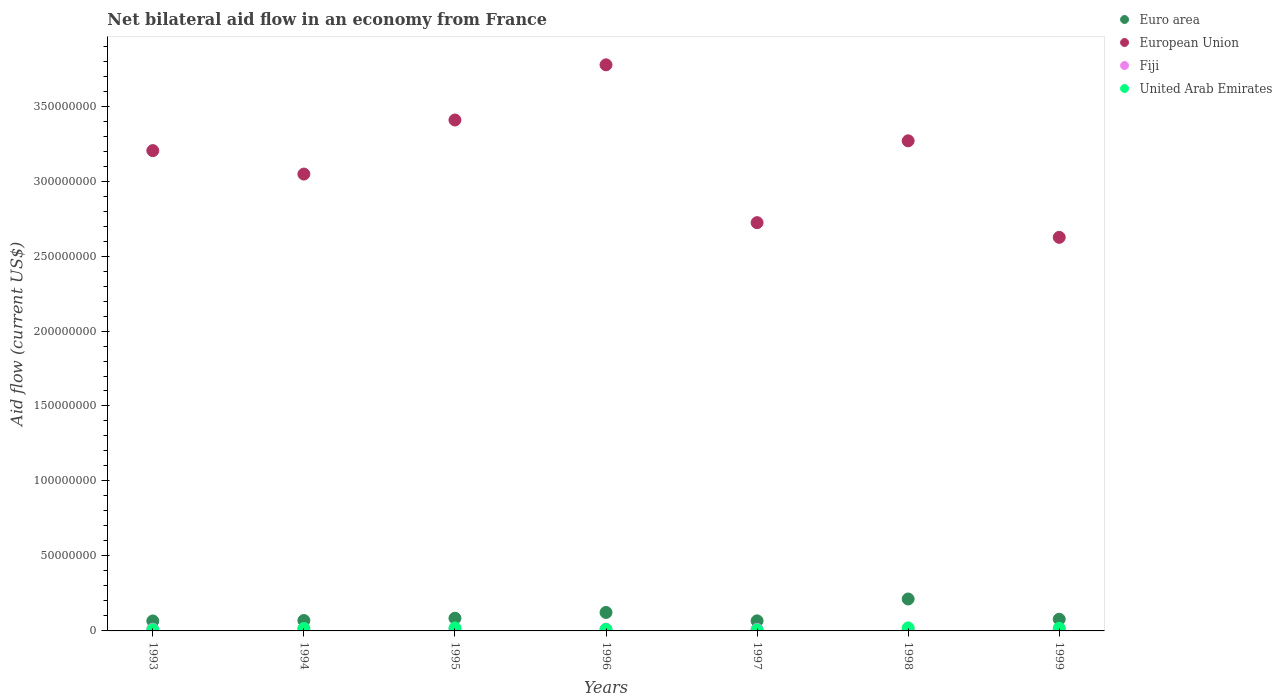How many different coloured dotlines are there?
Your answer should be very brief. 4. What is the net bilateral aid flow in Euro area in 1995?
Offer a very short reply. 8.47e+06. Across all years, what is the maximum net bilateral aid flow in European Union?
Ensure brevity in your answer.  3.78e+08. Across all years, what is the minimum net bilateral aid flow in European Union?
Give a very brief answer. 2.62e+08. In which year was the net bilateral aid flow in United Arab Emirates minimum?
Provide a short and direct response. 1997. What is the total net bilateral aid flow in European Union in the graph?
Give a very brief answer. 2.20e+09. What is the difference between the net bilateral aid flow in United Arab Emirates in 1993 and that in 1995?
Offer a very short reply. -1.20e+06. What is the difference between the net bilateral aid flow in Euro area in 1993 and the net bilateral aid flow in United Arab Emirates in 1994?
Make the answer very short. 5.03e+06. What is the average net bilateral aid flow in European Union per year?
Make the answer very short. 3.15e+08. In the year 1998, what is the difference between the net bilateral aid flow in Fiji and net bilateral aid flow in European Union?
Make the answer very short. -3.26e+08. What is the ratio of the net bilateral aid flow in United Arab Emirates in 1993 to that in 1994?
Keep it short and to the point. 0.49. What is the difference between the highest and the second highest net bilateral aid flow in Euro area?
Provide a short and direct response. 8.98e+06. What is the difference between the highest and the lowest net bilateral aid flow in Fiji?
Ensure brevity in your answer.  7.90e+05. In how many years, is the net bilateral aid flow in Fiji greater than the average net bilateral aid flow in Fiji taken over all years?
Offer a very short reply. 4. Is it the case that in every year, the sum of the net bilateral aid flow in Fiji and net bilateral aid flow in United Arab Emirates  is greater than the net bilateral aid flow in European Union?
Offer a very short reply. No. Does the net bilateral aid flow in European Union monotonically increase over the years?
Give a very brief answer. No. Is the net bilateral aid flow in United Arab Emirates strictly less than the net bilateral aid flow in Euro area over the years?
Give a very brief answer. Yes. How many dotlines are there?
Make the answer very short. 4. Are the values on the major ticks of Y-axis written in scientific E-notation?
Offer a very short reply. No. Does the graph contain any zero values?
Make the answer very short. No. How many legend labels are there?
Make the answer very short. 4. What is the title of the graph?
Give a very brief answer. Net bilateral aid flow in an economy from France. Does "Canada" appear as one of the legend labels in the graph?
Make the answer very short. No. What is the Aid flow (current US$) of Euro area in 1993?
Give a very brief answer. 6.64e+06. What is the Aid flow (current US$) of European Union in 1993?
Make the answer very short. 3.20e+08. What is the Aid flow (current US$) of Fiji in 1993?
Offer a terse response. 1.17e+06. What is the Aid flow (current US$) of United Arab Emirates in 1993?
Provide a short and direct response. 7.90e+05. What is the Aid flow (current US$) in Euro area in 1994?
Give a very brief answer. 6.94e+06. What is the Aid flow (current US$) in European Union in 1994?
Your answer should be very brief. 3.05e+08. What is the Aid flow (current US$) in Fiji in 1994?
Offer a very short reply. 1.35e+06. What is the Aid flow (current US$) in United Arab Emirates in 1994?
Provide a succinct answer. 1.61e+06. What is the Aid flow (current US$) of Euro area in 1995?
Your response must be concise. 8.47e+06. What is the Aid flow (current US$) in European Union in 1995?
Make the answer very short. 3.41e+08. What is the Aid flow (current US$) in Fiji in 1995?
Your answer should be compact. 8.20e+05. What is the Aid flow (current US$) of United Arab Emirates in 1995?
Offer a terse response. 1.99e+06. What is the Aid flow (current US$) in Euro area in 1996?
Your response must be concise. 1.23e+07. What is the Aid flow (current US$) in European Union in 1996?
Offer a terse response. 3.78e+08. What is the Aid flow (current US$) of Fiji in 1996?
Keep it short and to the point. 1.21e+06. What is the Aid flow (current US$) of Euro area in 1997?
Ensure brevity in your answer.  6.72e+06. What is the Aid flow (current US$) of European Union in 1997?
Provide a succinct answer. 2.72e+08. What is the Aid flow (current US$) in Fiji in 1997?
Provide a short and direct response. 1.03e+06. What is the Aid flow (current US$) of United Arab Emirates in 1997?
Offer a very short reply. 6.50e+05. What is the Aid flow (current US$) of Euro area in 1998?
Offer a terse response. 2.13e+07. What is the Aid flow (current US$) of European Union in 1998?
Your response must be concise. 3.27e+08. What is the Aid flow (current US$) of Fiji in 1998?
Keep it short and to the point. 5.60e+05. What is the Aid flow (current US$) of United Arab Emirates in 1998?
Your answer should be very brief. 2.02e+06. What is the Aid flow (current US$) in Euro area in 1999?
Your response must be concise. 7.79e+06. What is the Aid flow (current US$) of European Union in 1999?
Ensure brevity in your answer.  2.62e+08. What is the Aid flow (current US$) of Fiji in 1999?
Make the answer very short. 1.15e+06. What is the Aid flow (current US$) of United Arab Emirates in 1999?
Make the answer very short. 1.75e+06. Across all years, what is the maximum Aid flow (current US$) of Euro area?
Provide a succinct answer. 2.13e+07. Across all years, what is the maximum Aid flow (current US$) in European Union?
Your answer should be very brief. 3.78e+08. Across all years, what is the maximum Aid flow (current US$) of Fiji?
Provide a short and direct response. 1.35e+06. Across all years, what is the maximum Aid flow (current US$) of United Arab Emirates?
Make the answer very short. 2.02e+06. Across all years, what is the minimum Aid flow (current US$) of Euro area?
Ensure brevity in your answer.  6.64e+06. Across all years, what is the minimum Aid flow (current US$) of European Union?
Provide a short and direct response. 2.62e+08. Across all years, what is the minimum Aid flow (current US$) in Fiji?
Ensure brevity in your answer.  5.60e+05. Across all years, what is the minimum Aid flow (current US$) in United Arab Emirates?
Give a very brief answer. 6.50e+05. What is the total Aid flow (current US$) in Euro area in the graph?
Make the answer very short. 7.02e+07. What is the total Aid flow (current US$) of European Union in the graph?
Your response must be concise. 2.20e+09. What is the total Aid flow (current US$) in Fiji in the graph?
Keep it short and to the point. 7.29e+06. What is the total Aid flow (current US$) in United Arab Emirates in the graph?
Your response must be concise. 9.81e+06. What is the difference between the Aid flow (current US$) in Euro area in 1993 and that in 1994?
Provide a succinct answer. -3.00e+05. What is the difference between the Aid flow (current US$) of European Union in 1993 and that in 1994?
Keep it short and to the point. 1.56e+07. What is the difference between the Aid flow (current US$) in Fiji in 1993 and that in 1994?
Offer a terse response. -1.80e+05. What is the difference between the Aid flow (current US$) of United Arab Emirates in 1993 and that in 1994?
Provide a short and direct response. -8.20e+05. What is the difference between the Aid flow (current US$) in Euro area in 1993 and that in 1995?
Keep it short and to the point. -1.83e+06. What is the difference between the Aid flow (current US$) of European Union in 1993 and that in 1995?
Your answer should be compact. -2.04e+07. What is the difference between the Aid flow (current US$) of United Arab Emirates in 1993 and that in 1995?
Ensure brevity in your answer.  -1.20e+06. What is the difference between the Aid flow (current US$) in Euro area in 1993 and that in 1996?
Keep it short and to the point. -5.67e+06. What is the difference between the Aid flow (current US$) in European Union in 1993 and that in 1996?
Your answer should be very brief. -5.72e+07. What is the difference between the Aid flow (current US$) of European Union in 1993 and that in 1997?
Offer a very short reply. 4.80e+07. What is the difference between the Aid flow (current US$) of United Arab Emirates in 1993 and that in 1997?
Keep it short and to the point. 1.40e+05. What is the difference between the Aid flow (current US$) of Euro area in 1993 and that in 1998?
Your answer should be compact. -1.46e+07. What is the difference between the Aid flow (current US$) of European Union in 1993 and that in 1998?
Ensure brevity in your answer.  -6.53e+06. What is the difference between the Aid flow (current US$) in United Arab Emirates in 1993 and that in 1998?
Your response must be concise. -1.23e+06. What is the difference between the Aid flow (current US$) in Euro area in 1993 and that in 1999?
Your response must be concise. -1.15e+06. What is the difference between the Aid flow (current US$) in European Union in 1993 and that in 1999?
Give a very brief answer. 5.78e+07. What is the difference between the Aid flow (current US$) in United Arab Emirates in 1993 and that in 1999?
Provide a short and direct response. -9.60e+05. What is the difference between the Aid flow (current US$) in Euro area in 1994 and that in 1995?
Provide a succinct answer. -1.53e+06. What is the difference between the Aid flow (current US$) of European Union in 1994 and that in 1995?
Provide a succinct answer. -3.61e+07. What is the difference between the Aid flow (current US$) of Fiji in 1994 and that in 1995?
Your answer should be very brief. 5.30e+05. What is the difference between the Aid flow (current US$) in United Arab Emirates in 1994 and that in 1995?
Your response must be concise. -3.80e+05. What is the difference between the Aid flow (current US$) of Euro area in 1994 and that in 1996?
Offer a terse response. -5.37e+06. What is the difference between the Aid flow (current US$) in European Union in 1994 and that in 1996?
Make the answer very short. -7.28e+07. What is the difference between the Aid flow (current US$) of Fiji in 1994 and that in 1996?
Ensure brevity in your answer.  1.40e+05. What is the difference between the Aid flow (current US$) of Euro area in 1994 and that in 1997?
Your answer should be compact. 2.20e+05. What is the difference between the Aid flow (current US$) of European Union in 1994 and that in 1997?
Provide a succinct answer. 3.24e+07. What is the difference between the Aid flow (current US$) in United Arab Emirates in 1994 and that in 1997?
Offer a very short reply. 9.60e+05. What is the difference between the Aid flow (current US$) in Euro area in 1994 and that in 1998?
Your answer should be compact. -1.44e+07. What is the difference between the Aid flow (current US$) of European Union in 1994 and that in 1998?
Make the answer very short. -2.22e+07. What is the difference between the Aid flow (current US$) of Fiji in 1994 and that in 1998?
Offer a very short reply. 7.90e+05. What is the difference between the Aid flow (current US$) in United Arab Emirates in 1994 and that in 1998?
Keep it short and to the point. -4.10e+05. What is the difference between the Aid flow (current US$) in Euro area in 1994 and that in 1999?
Provide a short and direct response. -8.50e+05. What is the difference between the Aid flow (current US$) of European Union in 1994 and that in 1999?
Ensure brevity in your answer.  4.22e+07. What is the difference between the Aid flow (current US$) of United Arab Emirates in 1994 and that in 1999?
Your answer should be compact. -1.40e+05. What is the difference between the Aid flow (current US$) of Euro area in 1995 and that in 1996?
Make the answer very short. -3.84e+06. What is the difference between the Aid flow (current US$) of European Union in 1995 and that in 1996?
Ensure brevity in your answer.  -3.68e+07. What is the difference between the Aid flow (current US$) in Fiji in 1995 and that in 1996?
Provide a succinct answer. -3.90e+05. What is the difference between the Aid flow (current US$) in United Arab Emirates in 1995 and that in 1996?
Keep it short and to the point. 9.90e+05. What is the difference between the Aid flow (current US$) of Euro area in 1995 and that in 1997?
Your answer should be very brief. 1.75e+06. What is the difference between the Aid flow (current US$) of European Union in 1995 and that in 1997?
Ensure brevity in your answer.  6.85e+07. What is the difference between the Aid flow (current US$) in United Arab Emirates in 1995 and that in 1997?
Offer a terse response. 1.34e+06. What is the difference between the Aid flow (current US$) in Euro area in 1995 and that in 1998?
Provide a succinct answer. -1.28e+07. What is the difference between the Aid flow (current US$) of European Union in 1995 and that in 1998?
Your answer should be compact. 1.39e+07. What is the difference between the Aid flow (current US$) of Euro area in 1995 and that in 1999?
Provide a succinct answer. 6.80e+05. What is the difference between the Aid flow (current US$) of European Union in 1995 and that in 1999?
Give a very brief answer. 7.83e+07. What is the difference between the Aid flow (current US$) in Fiji in 1995 and that in 1999?
Your response must be concise. -3.30e+05. What is the difference between the Aid flow (current US$) in Euro area in 1996 and that in 1997?
Your answer should be very brief. 5.59e+06. What is the difference between the Aid flow (current US$) in European Union in 1996 and that in 1997?
Offer a very short reply. 1.05e+08. What is the difference between the Aid flow (current US$) of United Arab Emirates in 1996 and that in 1997?
Make the answer very short. 3.50e+05. What is the difference between the Aid flow (current US$) of Euro area in 1996 and that in 1998?
Your answer should be very brief. -8.98e+06. What is the difference between the Aid flow (current US$) of European Union in 1996 and that in 1998?
Offer a terse response. 5.07e+07. What is the difference between the Aid flow (current US$) in Fiji in 1996 and that in 1998?
Give a very brief answer. 6.50e+05. What is the difference between the Aid flow (current US$) of United Arab Emirates in 1996 and that in 1998?
Make the answer very short. -1.02e+06. What is the difference between the Aid flow (current US$) of Euro area in 1996 and that in 1999?
Provide a short and direct response. 4.52e+06. What is the difference between the Aid flow (current US$) in European Union in 1996 and that in 1999?
Your answer should be very brief. 1.15e+08. What is the difference between the Aid flow (current US$) of Fiji in 1996 and that in 1999?
Provide a short and direct response. 6.00e+04. What is the difference between the Aid flow (current US$) of United Arab Emirates in 1996 and that in 1999?
Your answer should be very brief. -7.50e+05. What is the difference between the Aid flow (current US$) in Euro area in 1997 and that in 1998?
Provide a succinct answer. -1.46e+07. What is the difference between the Aid flow (current US$) in European Union in 1997 and that in 1998?
Your response must be concise. -5.46e+07. What is the difference between the Aid flow (current US$) in Fiji in 1997 and that in 1998?
Offer a very short reply. 4.70e+05. What is the difference between the Aid flow (current US$) in United Arab Emirates in 1997 and that in 1998?
Give a very brief answer. -1.37e+06. What is the difference between the Aid flow (current US$) of Euro area in 1997 and that in 1999?
Your answer should be very brief. -1.07e+06. What is the difference between the Aid flow (current US$) in European Union in 1997 and that in 1999?
Provide a succinct answer. 9.80e+06. What is the difference between the Aid flow (current US$) of United Arab Emirates in 1997 and that in 1999?
Ensure brevity in your answer.  -1.10e+06. What is the difference between the Aid flow (current US$) of Euro area in 1998 and that in 1999?
Offer a very short reply. 1.35e+07. What is the difference between the Aid flow (current US$) of European Union in 1998 and that in 1999?
Give a very brief answer. 6.44e+07. What is the difference between the Aid flow (current US$) of Fiji in 1998 and that in 1999?
Give a very brief answer. -5.90e+05. What is the difference between the Aid flow (current US$) in United Arab Emirates in 1998 and that in 1999?
Provide a short and direct response. 2.70e+05. What is the difference between the Aid flow (current US$) of Euro area in 1993 and the Aid flow (current US$) of European Union in 1994?
Give a very brief answer. -2.98e+08. What is the difference between the Aid flow (current US$) of Euro area in 1993 and the Aid flow (current US$) of Fiji in 1994?
Your response must be concise. 5.29e+06. What is the difference between the Aid flow (current US$) of Euro area in 1993 and the Aid flow (current US$) of United Arab Emirates in 1994?
Offer a very short reply. 5.03e+06. What is the difference between the Aid flow (current US$) of European Union in 1993 and the Aid flow (current US$) of Fiji in 1994?
Provide a short and direct response. 3.19e+08. What is the difference between the Aid flow (current US$) in European Union in 1993 and the Aid flow (current US$) in United Arab Emirates in 1994?
Your answer should be compact. 3.19e+08. What is the difference between the Aid flow (current US$) in Fiji in 1993 and the Aid flow (current US$) in United Arab Emirates in 1994?
Ensure brevity in your answer.  -4.40e+05. What is the difference between the Aid flow (current US$) in Euro area in 1993 and the Aid flow (current US$) in European Union in 1995?
Keep it short and to the point. -3.34e+08. What is the difference between the Aid flow (current US$) in Euro area in 1993 and the Aid flow (current US$) in Fiji in 1995?
Your answer should be compact. 5.82e+06. What is the difference between the Aid flow (current US$) of Euro area in 1993 and the Aid flow (current US$) of United Arab Emirates in 1995?
Your answer should be compact. 4.65e+06. What is the difference between the Aid flow (current US$) of European Union in 1993 and the Aid flow (current US$) of Fiji in 1995?
Offer a very short reply. 3.19e+08. What is the difference between the Aid flow (current US$) of European Union in 1993 and the Aid flow (current US$) of United Arab Emirates in 1995?
Keep it short and to the point. 3.18e+08. What is the difference between the Aid flow (current US$) of Fiji in 1993 and the Aid flow (current US$) of United Arab Emirates in 1995?
Make the answer very short. -8.20e+05. What is the difference between the Aid flow (current US$) in Euro area in 1993 and the Aid flow (current US$) in European Union in 1996?
Provide a short and direct response. -3.71e+08. What is the difference between the Aid flow (current US$) in Euro area in 1993 and the Aid flow (current US$) in Fiji in 1996?
Offer a terse response. 5.43e+06. What is the difference between the Aid flow (current US$) in Euro area in 1993 and the Aid flow (current US$) in United Arab Emirates in 1996?
Offer a very short reply. 5.64e+06. What is the difference between the Aid flow (current US$) of European Union in 1993 and the Aid flow (current US$) of Fiji in 1996?
Keep it short and to the point. 3.19e+08. What is the difference between the Aid flow (current US$) of European Union in 1993 and the Aid flow (current US$) of United Arab Emirates in 1996?
Your response must be concise. 3.19e+08. What is the difference between the Aid flow (current US$) of Euro area in 1993 and the Aid flow (current US$) of European Union in 1997?
Provide a succinct answer. -2.66e+08. What is the difference between the Aid flow (current US$) in Euro area in 1993 and the Aid flow (current US$) in Fiji in 1997?
Give a very brief answer. 5.61e+06. What is the difference between the Aid flow (current US$) in Euro area in 1993 and the Aid flow (current US$) in United Arab Emirates in 1997?
Provide a short and direct response. 5.99e+06. What is the difference between the Aid flow (current US$) of European Union in 1993 and the Aid flow (current US$) of Fiji in 1997?
Make the answer very short. 3.19e+08. What is the difference between the Aid flow (current US$) in European Union in 1993 and the Aid flow (current US$) in United Arab Emirates in 1997?
Provide a succinct answer. 3.20e+08. What is the difference between the Aid flow (current US$) of Fiji in 1993 and the Aid flow (current US$) of United Arab Emirates in 1997?
Offer a very short reply. 5.20e+05. What is the difference between the Aid flow (current US$) in Euro area in 1993 and the Aid flow (current US$) in European Union in 1998?
Offer a very short reply. -3.20e+08. What is the difference between the Aid flow (current US$) of Euro area in 1993 and the Aid flow (current US$) of Fiji in 1998?
Keep it short and to the point. 6.08e+06. What is the difference between the Aid flow (current US$) of Euro area in 1993 and the Aid flow (current US$) of United Arab Emirates in 1998?
Your answer should be compact. 4.62e+06. What is the difference between the Aid flow (current US$) of European Union in 1993 and the Aid flow (current US$) of Fiji in 1998?
Your answer should be compact. 3.20e+08. What is the difference between the Aid flow (current US$) of European Union in 1993 and the Aid flow (current US$) of United Arab Emirates in 1998?
Your answer should be very brief. 3.18e+08. What is the difference between the Aid flow (current US$) in Fiji in 1993 and the Aid flow (current US$) in United Arab Emirates in 1998?
Your answer should be very brief. -8.50e+05. What is the difference between the Aid flow (current US$) of Euro area in 1993 and the Aid flow (current US$) of European Union in 1999?
Your answer should be compact. -2.56e+08. What is the difference between the Aid flow (current US$) in Euro area in 1993 and the Aid flow (current US$) in Fiji in 1999?
Ensure brevity in your answer.  5.49e+06. What is the difference between the Aid flow (current US$) of Euro area in 1993 and the Aid flow (current US$) of United Arab Emirates in 1999?
Give a very brief answer. 4.89e+06. What is the difference between the Aid flow (current US$) in European Union in 1993 and the Aid flow (current US$) in Fiji in 1999?
Offer a terse response. 3.19e+08. What is the difference between the Aid flow (current US$) of European Union in 1993 and the Aid flow (current US$) of United Arab Emirates in 1999?
Give a very brief answer. 3.19e+08. What is the difference between the Aid flow (current US$) in Fiji in 1993 and the Aid flow (current US$) in United Arab Emirates in 1999?
Offer a terse response. -5.80e+05. What is the difference between the Aid flow (current US$) of Euro area in 1994 and the Aid flow (current US$) of European Union in 1995?
Your response must be concise. -3.34e+08. What is the difference between the Aid flow (current US$) in Euro area in 1994 and the Aid flow (current US$) in Fiji in 1995?
Provide a succinct answer. 6.12e+06. What is the difference between the Aid flow (current US$) of Euro area in 1994 and the Aid flow (current US$) of United Arab Emirates in 1995?
Provide a succinct answer. 4.95e+06. What is the difference between the Aid flow (current US$) of European Union in 1994 and the Aid flow (current US$) of Fiji in 1995?
Ensure brevity in your answer.  3.04e+08. What is the difference between the Aid flow (current US$) of European Union in 1994 and the Aid flow (current US$) of United Arab Emirates in 1995?
Make the answer very short. 3.03e+08. What is the difference between the Aid flow (current US$) of Fiji in 1994 and the Aid flow (current US$) of United Arab Emirates in 1995?
Make the answer very short. -6.40e+05. What is the difference between the Aid flow (current US$) in Euro area in 1994 and the Aid flow (current US$) in European Union in 1996?
Give a very brief answer. -3.71e+08. What is the difference between the Aid flow (current US$) in Euro area in 1994 and the Aid flow (current US$) in Fiji in 1996?
Provide a succinct answer. 5.73e+06. What is the difference between the Aid flow (current US$) in Euro area in 1994 and the Aid flow (current US$) in United Arab Emirates in 1996?
Provide a short and direct response. 5.94e+06. What is the difference between the Aid flow (current US$) in European Union in 1994 and the Aid flow (current US$) in Fiji in 1996?
Provide a short and direct response. 3.03e+08. What is the difference between the Aid flow (current US$) in European Union in 1994 and the Aid flow (current US$) in United Arab Emirates in 1996?
Offer a terse response. 3.04e+08. What is the difference between the Aid flow (current US$) of Fiji in 1994 and the Aid flow (current US$) of United Arab Emirates in 1996?
Your answer should be compact. 3.50e+05. What is the difference between the Aid flow (current US$) in Euro area in 1994 and the Aid flow (current US$) in European Union in 1997?
Make the answer very short. -2.65e+08. What is the difference between the Aid flow (current US$) of Euro area in 1994 and the Aid flow (current US$) of Fiji in 1997?
Offer a terse response. 5.91e+06. What is the difference between the Aid flow (current US$) in Euro area in 1994 and the Aid flow (current US$) in United Arab Emirates in 1997?
Your answer should be compact. 6.29e+06. What is the difference between the Aid flow (current US$) of European Union in 1994 and the Aid flow (current US$) of Fiji in 1997?
Offer a very short reply. 3.04e+08. What is the difference between the Aid flow (current US$) of European Union in 1994 and the Aid flow (current US$) of United Arab Emirates in 1997?
Offer a very short reply. 3.04e+08. What is the difference between the Aid flow (current US$) in Fiji in 1994 and the Aid flow (current US$) in United Arab Emirates in 1997?
Your response must be concise. 7.00e+05. What is the difference between the Aid flow (current US$) of Euro area in 1994 and the Aid flow (current US$) of European Union in 1998?
Offer a terse response. -3.20e+08. What is the difference between the Aid flow (current US$) in Euro area in 1994 and the Aid flow (current US$) in Fiji in 1998?
Offer a very short reply. 6.38e+06. What is the difference between the Aid flow (current US$) in Euro area in 1994 and the Aid flow (current US$) in United Arab Emirates in 1998?
Offer a terse response. 4.92e+06. What is the difference between the Aid flow (current US$) in European Union in 1994 and the Aid flow (current US$) in Fiji in 1998?
Your answer should be compact. 3.04e+08. What is the difference between the Aid flow (current US$) in European Union in 1994 and the Aid flow (current US$) in United Arab Emirates in 1998?
Offer a very short reply. 3.03e+08. What is the difference between the Aid flow (current US$) of Fiji in 1994 and the Aid flow (current US$) of United Arab Emirates in 1998?
Your answer should be compact. -6.70e+05. What is the difference between the Aid flow (current US$) of Euro area in 1994 and the Aid flow (current US$) of European Union in 1999?
Offer a very short reply. -2.56e+08. What is the difference between the Aid flow (current US$) in Euro area in 1994 and the Aid flow (current US$) in Fiji in 1999?
Offer a terse response. 5.79e+06. What is the difference between the Aid flow (current US$) of Euro area in 1994 and the Aid flow (current US$) of United Arab Emirates in 1999?
Keep it short and to the point. 5.19e+06. What is the difference between the Aid flow (current US$) in European Union in 1994 and the Aid flow (current US$) in Fiji in 1999?
Offer a terse response. 3.04e+08. What is the difference between the Aid flow (current US$) of European Union in 1994 and the Aid flow (current US$) of United Arab Emirates in 1999?
Ensure brevity in your answer.  3.03e+08. What is the difference between the Aid flow (current US$) of Fiji in 1994 and the Aid flow (current US$) of United Arab Emirates in 1999?
Ensure brevity in your answer.  -4.00e+05. What is the difference between the Aid flow (current US$) in Euro area in 1995 and the Aid flow (current US$) in European Union in 1996?
Ensure brevity in your answer.  -3.69e+08. What is the difference between the Aid flow (current US$) of Euro area in 1995 and the Aid flow (current US$) of Fiji in 1996?
Your answer should be compact. 7.26e+06. What is the difference between the Aid flow (current US$) of Euro area in 1995 and the Aid flow (current US$) of United Arab Emirates in 1996?
Your answer should be compact. 7.47e+06. What is the difference between the Aid flow (current US$) in European Union in 1995 and the Aid flow (current US$) in Fiji in 1996?
Ensure brevity in your answer.  3.40e+08. What is the difference between the Aid flow (current US$) in European Union in 1995 and the Aid flow (current US$) in United Arab Emirates in 1996?
Provide a short and direct response. 3.40e+08. What is the difference between the Aid flow (current US$) of Euro area in 1995 and the Aid flow (current US$) of European Union in 1997?
Make the answer very short. -2.64e+08. What is the difference between the Aid flow (current US$) of Euro area in 1995 and the Aid flow (current US$) of Fiji in 1997?
Offer a terse response. 7.44e+06. What is the difference between the Aid flow (current US$) in Euro area in 1995 and the Aid flow (current US$) in United Arab Emirates in 1997?
Ensure brevity in your answer.  7.82e+06. What is the difference between the Aid flow (current US$) in European Union in 1995 and the Aid flow (current US$) in Fiji in 1997?
Keep it short and to the point. 3.40e+08. What is the difference between the Aid flow (current US$) in European Union in 1995 and the Aid flow (current US$) in United Arab Emirates in 1997?
Ensure brevity in your answer.  3.40e+08. What is the difference between the Aid flow (current US$) in Fiji in 1995 and the Aid flow (current US$) in United Arab Emirates in 1997?
Ensure brevity in your answer.  1.70e+05. What is the difference between the Aid flow (current US$) in Euro area in 1995 and the Aid flow (current US$) in European Union in 1998?
Keep it short and to the point. -3.18e+08. What is the difference between the Aid flow (current US$) in Euro area in 1995 and the Aid flow (current US$) in Fiji in 1998?
Provide a short and direct response. 7.91e+06. What is the difference between the Aid flow (current US$) of Euro area in 1995 and the Aid flow (current US$) of United Arab Emirates in 1998?
Provide a short and direct response. 6.45e+06. What is the difference between the Aid flow (current US$) of European Union in 1995 and the Aid flow (current US$) of Fiji in 1998?
Offer a terse response. 3.40e+08. What is the difference between the Aid flow (current US$) of European Union in 1995 and the Aid flow (current US$) of United Arab Emirates in 1998?
Your response must be concise. 3.39e+08. What is the difference between the Aid flow (current US$) of Fiji in 1995 and the Aid flow (current US$) of United Arab Emirates in 1998?
Ensure brevity in your answer.  -1.20e+06. What is the difference between the Aid flow (current US$) of Euro area in 1995 and the Aid flow (current US$) of European Union in 1999?
Make the answer very short. -2.54e+08. What is the difference between the Aid flow (current US$) of Euro area in 1995 and the Aid flow (current US$) of Fiji in 1999?
Provide a succinct answer. 7.32e+06. What is the difference between the Aid flow (current US$) of Euro area in 1995 and the Aid flow (current US$) of United Arab Emirates in 1999?
Keep it short and to the point. 6.72e+06. What is the difference between the Aid flow (current US$) in European Union in 1995 and the Aid flow (current US$) in Fiji in 1999?
Your answer should be very brief. 3.40e+08. What is the difference between the Aid flow (current US$) of European Union in 1995 and the Aid flow (current US$) of United Arab Emirates in 1999?
Give a very brief answer. 3.39e+08. What is the difference between the Aid flow (current US$) of Fiji in 1995 and the Aid flow (current US$) of United Arab Emirates in 1999?
Make the answer very short. -9.30e+05. What is the difference between the Aid flow (current US$) in Euro area in 1996 and the Aid flow (current US$) in European Union in 1997?
Your answer should be compact. -2.60e+08. What is the difference between the Aid flow (current US$) in Euro area in 1996 and the Aid flow (current US$) in Fiji in 1997?
Provide a short and direct response. 1.13e+07. What is the difference between the Aid flow (current US$) of Euro area in 1996 and the Aid flow (current US$) of United Arab Emirates in 1997?
Offer a very short reply. 1.17e+07. What is the difference between the Aid flow (current US$) of European Union in 1996 and the Aid flow (current US$) of Fiji in 1997?
Give a very brief answer. 3.76e+08. What is the difference between the Aid flow (current US$) of European Union in 1996 and the Aid flow (current US$) of United Arab Emirates in 1997?
Your answer should be compact. 3.77e+08. What is the difference between the Aid flow (current US$) in Fiji in 1996 and the Aid flow (current US$) in United Arab Emirates in 1997?
Give a very brief answer. 5.60e+05. What is the difference between the Aid flow (current US$) in Euro area in 1996 and the Aid flow (current US$) in European Union in 1998?
Provide a succinct answer. -3.15e+08. What is the difference between the Aid flow (current US$) of Euro area in 1996 and the Aid flow (current US$) of Fiji in 1998?
Make the answer very short. 1.18e+07. What is the difference between the Aid flow (current US$) in Euro area in 1996 and the Aid flow (current US$) in United Arab Emirates in 1998?
Ensure brevity in your answer.  1.03e+07. What is the difference between the Aid flow (current US$) in European Union in 1996 and the Aid flow (current US$) in Fiji in 1998?
Keep it short and to the point. 3.77e+08. What is the difference between the Aid flow (current US$) of European Union in 1996 and the Aid flow (current US$) of United Arab Emirates in 1998?
Offer a very short reply. 3.75e+08. What is the difference between the Aid flow (current US$) of Fiji in 1996 and the Aid flow (current US$) of United Arab Emirates in 1998?
Make the answer very short. -8.10e+05. What is the difference between the Aid flow (current US$) of Euro area in 1996 and the Aid flow (current US$) of European Union in 1999?
Offer a very short reply. -2.50e+08. What is the difference between the Aid flow (current US$) of Euro area in 1996 and the Aid flow (current US$) of Fiji in 1999?
Provide a short and direct response. 1.12e+07. What is the difference between the Aid flow (current US$) in Euro area in 1996 and the Aid flow (current US$) in United Arab Emirates in 1999?
Make the answer very short. 1.06e+07. What is the difference between the Aid flow (current US$) of European Union in 1996 and the Aid flow (current US$) of Fiji in 1999?
Offer a very short reply. 3.76e+08. What is the difference between the Aid flow (current US$) of European Union in 1996 and the Aid flow (current US$) of United Arab Emirates in 1999?
Offer a terse response. 3.76e+08. What is the difference between the Aid flow (current US$) in Fiji in 1996 and the Aid flow (current US$) in United Arab Emirates in 1999?
Provide a short and direct response. -5.40e+05. What is the difference between the Aid flow (current US$) in Euro area in 1997 and the Aid flow (current US$) in European Union in 1998?
Offer a very short reply. -3.20e+08. What is the difference between the Aid flow (current US$) of Euro area in 1997 and the Aid flow (current US$) of Fiji in 1998?
Keep it short and to the point. 6.16e+06. What is the difference between the Aid flow (current US$) of Euro area in 1997 and the Aid flow (current US$) of United Arab Emirates in 1998?
Give a very brief answer. 4.70e+06. What is the difference between the Aid flow (current US$) in European Union in 1997 and the Aid flow (current US$) in Fiji in 1998?
Keep it short and to the point. 2.72e+08. What is the difference between the Aid flow (current US$) of European Union in 1997 and the Aid flow (current US$) of United Arab Emirates in 1998?
Offer a very short reply. 2.70e+08. What is the difference between the Aid flow (current US$) of Fiji in 1997 and the Aid flow (current US$) of United Arab Emirates in 1998?
Your answer should be compact. -9.90e+05. What is the difference between the Aid flow (current US$) in Euro area in 1997 and the Aid flow (current US$) in European Union in 1999?
Keep it short and to the point. -2.56e+08. What is the difference between the Aid flow (current US$) of Euro area in 1997 and the Aid flow (current US$) of Fiji in 1999?
Your answer should be compact. 5.57e+06. What is the difference between the Aid flow (current US$) in Euro area in 1997 and the Aid flow (current US$) in United Arab Emirates in 1999?
Provide a succinct answer. 4.97e+06. What is the difference between the Aid flow (current US$) in European Union in 1997 and the Aid flow (current US$) in Fiji in 1999?
Provide a succinct answer. 2.71e+08. What is the difference between the Aid flow (current US$) in European Union in 1997 and the Aid flow (current US$) in United Arab Emirates in 1999?
Your answer should be very brief. 2.71e+08. What is the difference between the Aid flow (current US$) in Fiji in 1997 and the Aid flow (current US$) in United Arab Emirates in 1999?
Offer a terse response. -7.20e+05. What is the difference between the Aid flow (current US$) in Euro area in 1998 and the Aid flow (current US$) in European Union in 1999?
Ensure brevity in your answer.  -2.41e+08. What is the difference between the Aid flow (current US$) of Euro area in 1998 and the Aid flow (current US$) of Fiji in 1999?
Offer a terse response. 2.01e+07. What is the difference between the Aid flow (current US$) in Euro area in 1998 and the Aid flow (current US$) in United Arab Emirates in 1999?
Give a very brief answer. 1.95e+07. What is the difference between the Aid flow (current US$) of European Union in 1998 and the Aid flow (current US$) of Fiji in 1999?
Make the answer very short. 3.26e+08. What is the difference between the Aid flow (current US$) of European Union in 1998 and the Aid flow (current US$) of United Arab Emirates in 1999?
Your answer should be very brief. 3.25e+08. What is the difference between the Aid flow (current US$) in Fiji in 1998 and the Aid flow (current US$) in United Arab Emirates in 1999?
Make the answer very short. -1.19e+06. What is the average Aid flow (current US$) of Euro area per year?
Your answer should be very brief. 1.00e+07. What is the average Aid flow (current US$) in European Union per year?
Your response must be concise. 3.15e+08. What is the average Aid flow (current US$) of Fiji per year?
Ensure brevity in your answer.  1.04e+06. What is the average Aid flow (current US$) of United Arab Emirates per year?
Keep it short and to the point. 1.40e+06. In the year 1993, what is the difference between the Aid flow (current US$) of Euro area and Aid flow (current US$) of European Union?
Your response must be concise. -3.14e+08. In the year 1993, what is the difference between the Aid flow (current US$) of Euro area and Aid flow (current US$) of Fiji?
Keep it short and to the point. 5.47e+06. In the year 1993, what is the difference between the Aid flow (current US$) of Euro area and Aid flow (current US$) of United Arab Emirates?
Offer a terse response. 5.85e+06. In the year 1993, what is the difference between the Aid flow (current US$) in European Union and Aid flow (current US$) in Fiji?
Provide a succinct answer. 3.19e+08. In the year 1993, what is the difference between the Aid flow (current US$) in European Union and Aid flow (current US$) in United Arab Emirates?
Keep it short and to the point. 3.20e+08. In the year 1993, what is the difference between the Aid flow (current US$) in Fiji and Aid flow (current US$) in United Arab Emirates?
Your answer should be compact. 3.80e+05. In the year 1994, what is the difference between the Aid flow (current US$) of Euro area and Aid flow (current US$) of European Union?
Offer a very short reply. -2.98e+08. In the year 1994, what is the difference between the Aid flow (current US$) of Euro area and Aid flow (current US$) of Fiji?
Provide a succinct answer. 5.59e+06. In the year 1994, what is the difference between the Aid flow (current US$) in Euro area and Aid flow (current US$) in United Arab Emirates?
Make the answer very short. 5.33e+06. In the year 1994, what is the difference between the Aid flow (current US$) in European Union and Aid flow (current US$) in Fiji?
Your answer should be compact. 3.03e+08. In the year 1994, what is the difference between the Aid flow (current US$) in European Union and Aid flow (current US$) in United Arab Emirates?
Make the answer very short. 3.03e+08. In the year 1994, what is the difference between the Aid flow (current US$) of Fiji and Aid flow (current US$) of United Arab Emirates?
Your answer should be very brief. -2.60e+05. In the year 1995, what is the difference between the Aid flow (current US$) in Euro area and Aid flow (current US$) in European Union?
Your answer should be very brief. -3.32e+08. In the year 1995, what is the difference between the Aid flow (current US$) in Euro area and Aid flow (current US$) in Fiji?
Your answer should be compact. 7.65e+06. In the year 1995, what is the difference between the Aid flow (current US$) of Euro area and Aid flow (current US$) of United Arab Emirates?
Offer a terse response. 6.48e+06. In the year 1995, what is the difference between the Aid flow (current US$) in European Union and Aid flow (current US$) in Fiji?
Ensure brevity in your answer.  3.40e+08. In the year 1995, what is the difference between the Aid flow (current US$) in European Union and Aid flow (current US$) in United Arab Emirates?
Offer a terse response. 3.39e+08. In the year 1995, what is the difference between the Aid flow (current US$) in Fiji and Aid flow (current US$) in United Arab Emirates?
Provide a succinct answer. -1.17e+06. In the year 1996, what is the difference between the Aid flow (current US$) of Euro area and Aid flow (current US$) of European Union?
Make the answer very short. -3.65e+08. In the year 1996, what is the difference between the Aid flow (current US$) in Euro area and Aid flow (current US$) in Fiji?
Give a very brief answer. 1.11e+07. In the year 1996, what is the difference between the Aid flow (current US$) of Euro area and Aid flow (current US$) of United Arab Emirates?
Offer a very short reply. 1.13e+07. In the year 1996, what is the difference between the Aid flow (current US$) of European Union and Aid flow (current US$) of Fiji?
Give a very brief answer. 3.76e+08. In the year 1996, what is the difference between the Aid flow (current US$) in European Union and Aid flow (current US$) in United Arab Emirates?
Provide a short and direct response. 3.77e+08. In the year 1997, what is the difference between the Aid flow (current US$) of Euro area and Aid flow (current US$) of European Union?
Ensure brevity in your answer.  -2.66e+08. In the year 1997, what is the difference between the Aid flow (current US$) of Euro area and Aid flow (current US$) of Fiji?
Keep it short and to the point. 5.69e+06. In the year 1997, what is the difference between the Aid flow (current US$) in Euro area and Aid flow (current US$) in United Arab Emirates?
Make the answer very short. 6.07e+06. In the year 1997, what is the difference between the Aid flow (current US$) in European Union and Aid flow (current US$) in Fiji?
Your answer should be compact. 2.71e+08. In the year 1997, what is the difference between the Aid flow (current US$) in European Union and Aid flow (current US$) in United Arab Emirates?
Offer a terse response. 2.72e+08. In the year 1997, what is the difference between the Aid flow (current US$) of Fiji and Aid flow (current US$) of United Arab Emirates?
Your answer should be compact. 3.80e+05. In the year 1998, what is the difference between the Aid flow (current US$) in Euro area and Aid flow (current US$) in European Union?
Make the answer very short. -3.06e+08. In the year 1998, what is the difference between the Aid flow (current US$) in Euro area and Aid flow (current US$) in Fiji?
Offer a terse response. 2.07e+07. In the year 1998, what is the difference between the Aid flow (current US$) of Euro area and Aid flow (current US$) of United Arab Emirates?
Keep it short and to the point. 1.93e+07. In the year 1998, what is the difference between the Aid flow (current US$) in European Union and Aid flow (current US$) in Fiji?
Keep it short and to the point. 3.26e+08. In the year 1998, what is the difference between the Aid flow (current US$) of European Union and Aid flow (current US$) of United Arab Emirates?
Offer a terse response. 3.25e+08. In the year 1998, what is the difference between the Aid flow (current US$) of Fiji and Aid flow (current US$) of United Arab Emirates?
Make the answer very short. -1.46e+06. In the year 1999, what is the difference between the Aid flow (current US$) in Euro area and Aid flow (current US$) in European Union?
Your response must be concise. -2.55e+08. In the year 1999, what is the difference between the Aid flow (current US$) of Euro area and Aid flow (current US$) of Fiji?
Your answer should be very brief. 6.64e+06. In the year 1999, what is the difference between the Aid flow (current US$) in Euro area and Aid flow (current US$) in United Arab Emirates?
Make the answer very short. 6.04e+06. In the year 1999, what is the difference between the Aid flow (current US$) in European Union and Aid flow (current US$) in Fiji?
Your answer should be compact. 2.61e+08. In the year 1999, what is the difference between the Aid flow (current US$) of European Union and Aid flow (current US$) of United Arab Emirates?
Your answer should be compact. 2.61e+08. In the year 1999, what is the difference between the Aid flow (current US$) in Fiji and Aid flow (current US$) in United Arab Emirates?
Your answer should be compact. -6.00e+05. What is the ratio of the Aid flow (current US$) in Euro area in 1993 to that in 1994?
Offer a terse response. 0.96. What is the ratio of the Aid flow (current US$) of European Union in 1993 to that in 1994?
Ensure brevity in your answer.  1.05. What is the ratio of the Aid flow (current US$) of Fiji in 1993 to that in 1994?
Your response must be concise. 0.87. What is the ratio of the Aid flow (current US$) of United Arab Emirates in 1993 to that in 1994?
Your answer should be compact. 0.49. What is the ratio of the Aid flow (current US$) of Euro area in 1993 to that in 1995?
Offer a terse response. 0.78. What is the ratio of the Aid flow (current US$) in European Union in 1993 to that in 1995?
Offer a very short reply. 0.94. What is the ratio of the Aid flow (current US$) in Fiji in 1993 to that in 1995?
Your answer should be very brief. 1.43. What is the ratio of the Aid flow (current US$) in United Arab Emirates in 1993 to that in 1995?
Your answer should be compact. 0.4. What is the ratio of the Aid flow (current US$) in Euro area in 1993 to that in 1996?
Provide a succinct answer. 0.54. What is the ratio of the Aid flow (current US$) in European Union in 1993 to that in 1996?
Keep it short and to the point. 0.85. What is the ratio of the Aid flow (current US$) in Fiji in 1993 to that in 1996?
Give a very brief answer. 0.97. What is the ratio of the Aid flow (current US$) in United Arab Emirates in 1993 to that in 1996?
Offer a very short reply. 0.79. What is the ratio of the Aid flow (current US$) of European Union in 1993 to that in 1997?
Keep it short and to the point. 1.18. What is the ratio of the Aid flow (current US$) in Fiji in 1993 to that in 1997?
Your response must be concise. 1.14. What is the ratio of the Aid flow (current US$) of United Arab Emirates in 1993 to that in 1997?
Keep it short and to the point. 1.22. What is the ratio of the Aid flow (current US$) of Euro area in 1993 to that in 1998?
Make the answer very short. 0.31. What is the ratio of the Aid flow (current US$) in Fiji in 1993 to that in 1998?
Make the answer very short. 2.09. What is the ratio of the Aid flow (current US$) in United Arab Emirates in 1993 to that in 1998?
Ensure brevity in your answer.  0.39. What is the ratio of the Aid flow (current US$) in Euro area in 1993 to that in 1999?
Your answer should be compact. 0.85. What is the ratio of the Aid flow (current US$) in European Union in 1993 to that in 1999?
Give a very brief answer. 1.22. What is the ratio of the Aid flow (current US$) of Fiji in 1993 to that in 1999?
Make the answer very short. 1.02. What is the ratio of the Aid flow (current US$) in United Arab Emirates in 1993 to that in 1999?
Your answer should be compact. 0.45. What is the ratio of the Aid flow (current US$) of Euro area in 1994 to that in 1995?
Keep it short and to the point. 0.82. What is the ratio of the Aid flow (current US$) of European Union in 1994 to that in 1995?
Offer a very short reply. 0.89. What is the ratio of the Aid flow (current US$) of Fiji in 1994 to that in 1995?
Make the answer very short. 1.65. What is the ratio of the Aid flow (current US$) of United Arab Emirates in 1994 to that in 1995?
Offer a very short reply. 0.81. What is the ratio of the Aid flow (current US$) of Euro area in 1994 to that in 1996?
Your response must be concise. 0.56. What is the ratio of the Aid flow (current US$) of European Union in 1994 to that in 1996?
Your response must be concise. 0.81. What is the ratio of the Aid flow (current US$) of Fiji in 1994 to that in 1996?
Your answer should be very brief. 1.12. What is the ratio of the Aid flow (current US$) in United Arab Emirates in 1994 to that in 1996?
Your answer should be compact. 1.61. What is the ratio of the Aid flow (current US$) of Euro area in 1994 to that in 1997?
Provide a succinct answer. 1.03. What is the ratio of the Aid flow (current US$) of European Union in 1994 to that in 1997?
Keep it short and to the point. 1.12. What is the ratio of the Aid flow (current US$) in Fiji in 1994 to that in 1997?
Your answer should be very brief. 1.31. What is the ratio of the Aid flow (current US$) of United Arab Emirates in 1994 to that in 1997?
Make the answer very short. 2.48. What is the ratio of the Aid flow (current US$) of Euro area in 1994 to that in 1998?
Ensure brevity in your answer.  0.33. What is the ratio of the Aid flow (current US$) in European Union in 1994 to that in 1998?
Your answer should be compact. 0.93. What is the ratio of the Aid flow (current US$) in Fiji in 1994 to that in 1998?
Give a very brief answer. 2.41. What is the ratio of the Aid flow (current US$) in United Arab Emirates in 1994 to that in 1998?
Offer a terse response. 0.8. What is the ratio of the Aid flow (current US$) in Euro area in 1994 to that in 1999?
Provide a succinct answer. 0.89. What is the ratio of the Aid flow (current US$) in European Union in 1994 to that in 1999?
Provide a succinct answer. 1.16. What is the ratio of the Aid flow (current US$) in Fiji in 1994 to that in 1999?
Keep it short and to the point. 1.17. What is the ratio of the Aid flow (current US$) of United Arab Emirates in 1994 to that in 1999?
Your response must be concise. 0.92. What is the ratio of the Aid flow (current US$) of Euro area in 1995 to that in 1996?
Your answer should be very brief. 0.69. What is the ratio of the Aid flow (current US$) in European Union in 1995 to that in 1996?
Provide a short and direct response. 0.9. What is the ratio of the Aid flow (current US$) of Fiji in 1995 to that in 1996?
Provide a short and direct response. 0.68. What is the ratio of the Aid flow (current US$) of United Arab Emirates in 1995 to that in 1996?
Make the answer very short. 1.99. What is the ratio of the Aid flow (current US$) in Euro area in 1995 to that in 1997?
Your answer should be very brief. 1.26. What is the ratio of the Aid flow (current US$) in European Union in 1995 to that in 1997?
Keep it short and to the point. 1.25. What is the ratio of the Aid flow (current US$) in Fiji in 1995 to that in 1997?
Give a very brief answer. 0.8. What is the ratio of the Aid flow (current US$) in United Arab Emirates in 1995 to that in 1997?
Your answer should be compact. 3.06. What is the ratio of the Aid flow (current US$) in Euro area in 1995 to that in 1998?
Your answer should be compact. 0.4. What is the ratio of the Aid flow (current US$) in European Union in 1995 to that in 1998?
Keep it short and to the point. 1.04. What is the ratio of the Aid flow (current US$) in Fiji in 1995 to that in 1998?
Provide a short and direct response. 1.46. What is the ratio of the Aid flow (current US$) of United Arab Emirates in 1995 to that in 1998?
Make the answer very short. 0.99. What is the ratio of the Aid flow (current US$) in Euro area in 1995 to that in 1999?
Make the answer very short. 1.09. What is the ratio of the Aid flow (current US$) of European Union in 1995 to that in 1999?
Your response must be concise. 1.3. What is the ratio of the Aid flow (current US$) in Fiji in 1995 to that in 1999?
Your response must be concise. 0.71. What is the ratio of the Aid flow (current US$) in United Arab Emirates in 1995 to that in 1999?
Keep it short and to the point. 1.14. What is the ratio of the Aid flow (current US$) of Euro area in 1996 to that in 1997?
Ensure brevity in your answer.  1.83. What is the ratio of the Aid flow (current US$) of European Union in 1996 to that in 1997?
Give a very brief answer. 1.39. What is the ratio of the Aid flow (current US$) in Fiji in 1996 to that in 1997?
Your response must be concise. 1.17. What is the ratio of the Aid flow (current US$) in United Arab Emirates in 1996 to that in 1997?
Provide a short and direct response. 1.54. What is the ratio of the Aid flow (current US$) in Euro area in 1996 to that in 1998?
Provide a succinct answer. 0.58. What is the ratio of the Aid flow (current US$) in European Union in 1996 to that in 1998?
Give a very brief answer. 1.16. What is the ratio of the Aid flow (current US$) of Fiji in 1996 to that in 1998?
Make the answer very short. 2.16. What is the ratio of the Aid flow (current US$) in United Arab Emirates in 1996 to that in 1998?
Make the answer very short. 0.49. What is the ratio of the Aid flow (current US$) in Euro area in 1996 to that in 1999?
Your answer should be compact. 1.58. What is the ratio of the Aid flow (current US$) of European Union in 1996 to that in 1999?
Your response must be concise. 1.44. What is the ratio of the Aid flow (current US$) of Fiji in 1996 to that in 1999?
Ensure brevity in your answer.  1.05. What is the ratio of the Aid flow (current US$) in United Arab Emirates in 1996 to that in 1999?
Provide a succinct answer. 0.57. What is the ratio of the Aid flow (current US$) of Euro area in 1997 to that in 1998?
Your answer should be compact. 0.32. What is the ratio of the Aid flow (current US$) in European Union in 1997 to that in 1998?
Your answer should be very brief. 0.83. What is the ratio of the Aid flow (current US$) in Fiji in 1997 to that in 1998?
Ensure brevity in your answer.  1.84. What is the ratio of the Aid flow (current US$) in United Arab Emirates in 1997 to that in 1998?
Ensure brevity in your answer.  0.32. What is the ratio of the Aid flow (current US$) of Euro area in 1997 to that in 1999?
Ensure brevity in your answer.  0.86. What is the ratio of the Aid flow (current US$) of European Union in 1997 to that in 1999?
Your answer should be compact. 1.04. What is the ratio of the Aid flow (current US$) of Fiji in 1997 to that in 1999?
Your answer should be compact. 0.9. What is the ratio of the Aid flow (current US$) in United Arab Emirates in 1997 to that in 1999?
Your answer should be compact. 0.37. What is the ratio of the Aid flow (current US$) of Euro area in 1998 to that in 1999?
Offer a very short reply. 2.73. What is the ratio of the Aid flow (current US$) of European Union in 1998 to that in 1999?
Your answer should be compact. 1.25. What is the ratio of the Aid flow (current US$) in Fiji in 1998 to that in 1999?
Give a very brief answer. 0.49. What is the ratio of the Aid flow (current US$) in United Arab Emirates in 1998 to that in 1999?
Make the answer very short. 1.15. What is the difference between the highest and the second highest Aid flow (current US$) in Euro area?
Ensure brevity in your answer.  8.98e+06. What is the difference between the highest and the second highest Aid flow (current US$) in European Union?
Keep it short and to the point. 3.68e+07. What is the difference between the highest and the second highest Aid flow (current US$) in Fiji?
Offer a very short reply. 1.40e+05. What is the difference between the highest and the lowest Aid flow (current US$) of Euro area?
Your answer should be compact. 1.46e+07. What is the difference between the highest and the lowest Aid flow (current US$) in European Union?
Give a very brief answer. 1.15e+08. What is the difference between the highest and the lowest Aid flow (current US$) of Fiji?
Ensure brevity in your answer.  7.90e+05. What is the difference between the highest and the lowest Aid flow (current US$) in United Arab Emirates?
Keep it short and to the point. 1.37e+06. 